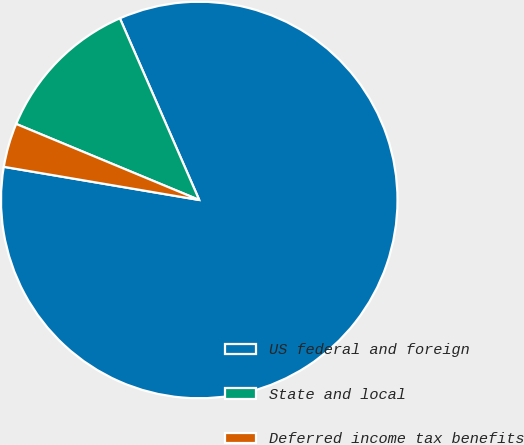Convert chart to OTSL. <chart><loc_0><loc_0><loc_500><loc_500><pie_chart><fcel>US federal and foreign<fcel>State and local<fcel>Deferred income tax benefits<nl><fcel>84.23%<fcel>12.18%<fcel>3.59%<nl></chart> 